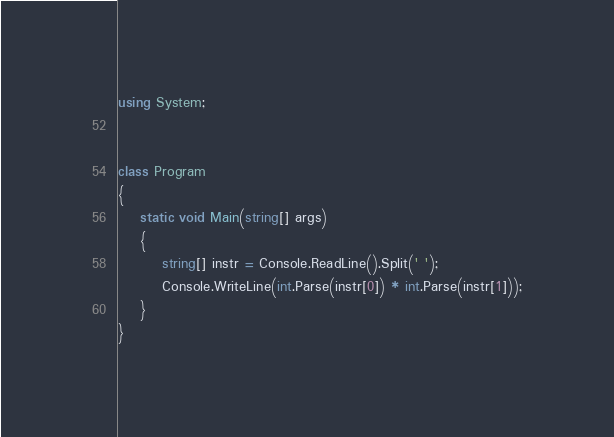Convert code to text. <code><loc_0><loc_0><loc_500><loc_500><_C#_>using System;


class Program
{
    static void Main(string[] args)
    {
        string[] instr = Console.ReadLine().Split(' ');
        Console.WriteLine(int.Parse(instr[0]) * int.Parse(instr[1]));
    }
}
</code> 